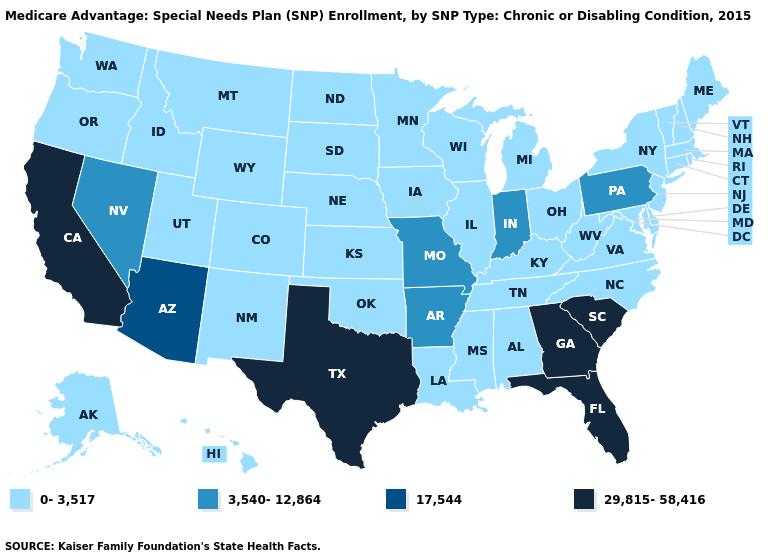Name the states that have a value in the range 29,815-58,416?
Give a very brief answer. California, Florida, Georgia, South Carolina, Texas. Which states have the lowest value in the USA?
Give a very brief answer. Alaska, Alabama, Colorado, Connecticut, Delaware, Hawaii, Iowa, Idaho, Illinois, Kansas, Kentucky, Louisiana, Massachusetts, Maryland, Maine, Michigan, Minnesota, Mississippi, Montana, North Carolina, North Dakota, Nebraska, New Hampshire, New Jersey, New Mexico, New York, Ohio, Oklahoma, Oregon, Rhode Island, South Dakota, Tennessee, Utah, Virginia, Vermont, Washington, Wisconsin, West Virginia, Wyoming. Name the states that have a value in the range 0-3,517?
Give a very brief answer. Alaska, Alabama, Colorado, Connecticut, Delaware, Hawaii, Iowa, Idaho, Illinois, Kansas, Kentucky, Louisiana, Massachusetts, Maryland, Maine, Michigan, Minnesota, Mississippi, Montana, North Carolina, North Dakota, Nebraska, New Hampshire, New Jersey, New Mexico, New York, Ohio, Oklahoma, Oregon, Rhode Island, South Dakota, Tennessee, Utah, Virginia, Vermont, Washington, Wisconsin, West Virginia, Wyoming. What is the value of Kansas?
Short answer required. 0-3,517. Which states hav the highest value in the Northeast?
Quick response, please. Pennsylvania. Does South Dakota have a lower value than Oklahoma?
Keep it brief. No. What is the value of Utah?
Short answer required. 0-3,517. Which states have the highest value in the USA?
Write a very short answer. California, Florida, Georgia, South Carolina, Texas. Name the states that have a value in the range 17,544?
Short answer required. Arizona. What is the lowest value in the USA?
Answer briefly. 0-3,517. Does Michigan have the lowest value in the USA?
Short answer required. Yes. How many symbols are there in the legend?
Be succinct. 4. Which states have the lowest value in the USA?
Short answer required. Alaska, Alabama, Colorado, Connecticut, Delaware, Hawaii, Iowa, Idaho, Illinois, Kansas, Kentucky, Louisiana, Massachusetts, Maryland, Maine, Michigan, Minnesota, Mississippi, Montana, North Carolina, North Dakota, Nebraska, New Hampshire, New Jersey, New Mexico, New York, Ohio, Oklahoma, Oregon, Rhode Island, South Dakota, Tennessee, Utah, Virginia, Vermont, Washington, Wisconsin, West Virginia, Wyoming. What is the value of Montana?
Quick response, please. 0-3,517. 